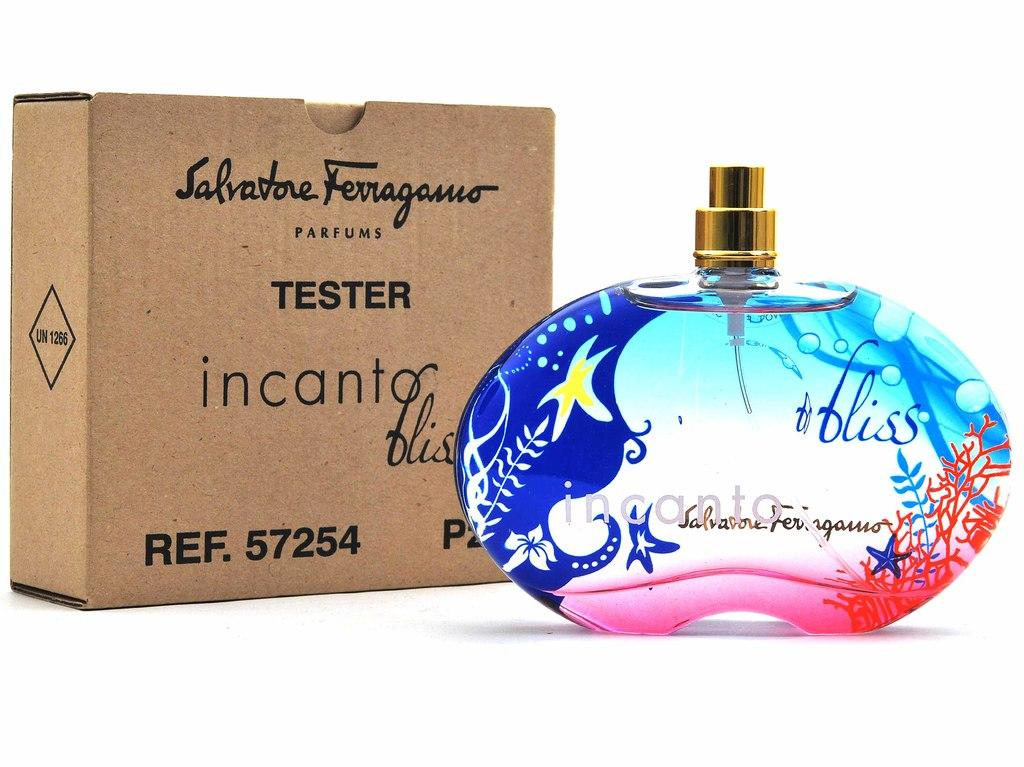<image>
Relay a brief, clear account of the picture shown. a box with the name tester written on it 